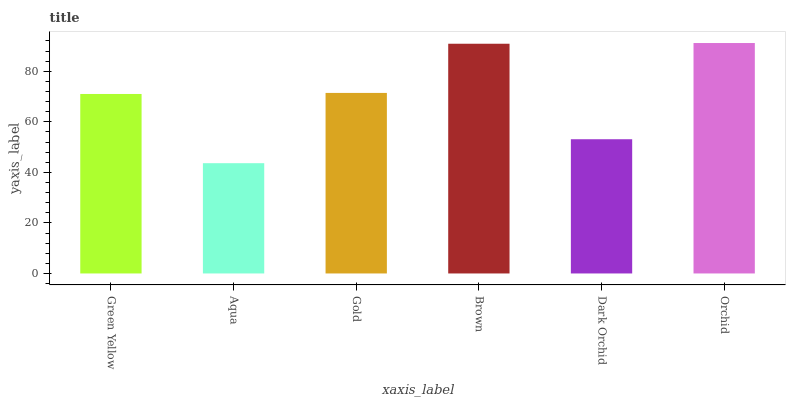Is Gold the minimum?
Answer yes or no. No. Is Gold the maximum?
Answer yes or no. No. Is Gold greater than Aqua?
Answer yes or no. Yes. Is Aqua less than Gold?
Answer yes or no. Yes. Is Aqua greater than Gold?
Answer yes or no. No. Is Gold less than Aqua?
Answer yes or no. No. Is Gold the high median?
Answer yes or no. Yes. Is Green Yellow the low median?
Answer yes or no. Yes. Is Aqua the high median?
Answer yes or no. No. Is Gold the low median?
Answer yes or no. No. 